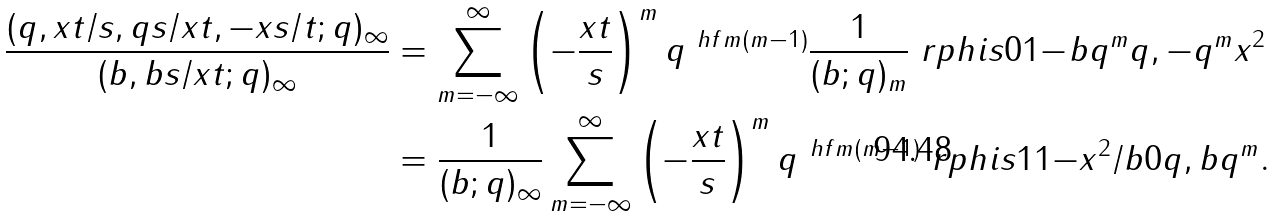<formula> <loc_0><loc_0><loc_500><loc_500>\frac { ( q , x t / s , q s / x t , - x s / t ; q ) _ { \infty } } { ( b , b s / x t ; q ) _ { \infty } } & = \sum _ { m = - \infty } ^ { \infty } \left ( - \frac { x t } { s } \right ) ^ { m } q ^ { \ h f m ( m - 1 ) } \frac { 1 } { ( b ; q ) _ { m } } \ r p h i s { 0 } { 1 } { - } { b q ^ { m } } { q , - q ^ { m } x ^ { 2 } } \\ & = \frac { 1 } { ( b ; q ) _ { \infty } } \sum _ { m = - \infty } ^ { \infty } \left ( - \frac { x t } { s } \right ) ^ { m } q ^ { \ h f m ( m - 1 ) } \ r p h i s { 1 } { 1 } { - x ^ { 2 } / b } { 0 } { q , b q ^ { m } } .</formula> 